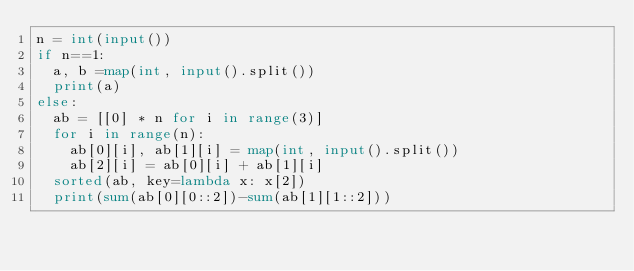Convert code to text. <code><loc_0><loc_0><loc_500><loc_500><_Python_>n = int(input())
if n==1:
  a, b =map(int, input().split())
  print(a)
else:
  ab = [[0] * n for i in range(3)]
  for i in range(n):
    ab[0][i], ab[1][i] = map(int, input().split())
    ab[2][i] = ab[0][i] + ab[1][i]
  sorted(ab, key=lambda x: x[2])
  print(sum(ab[0][0::2])-sum(ab[1][1::2]))
</code> 